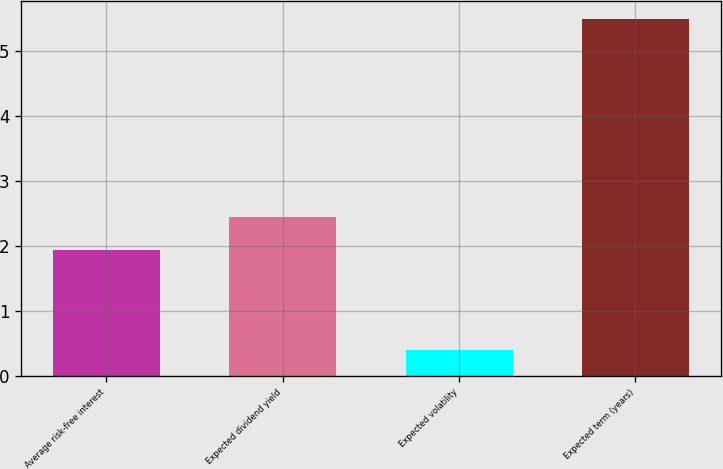Convert chart. <chart><loc_0><loc_0><loc_500><loc_500><bar_chart><fcel>Average risk-free interest<fcel>Expected dividend yield<fcel>Expected volatility<fcel>Expected term (years)<nl><fcel>1.94<fcel>2.45<fcel>0.39<fcel>5.5<nl></chart> 